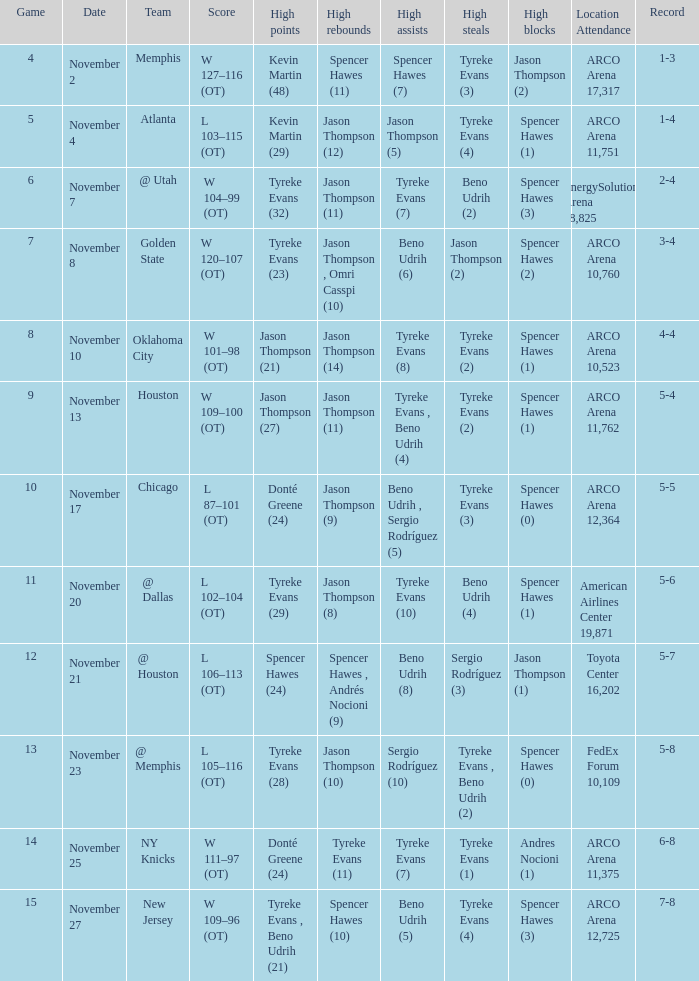If the record is 5-5, what is the game maximum? 10.0. 